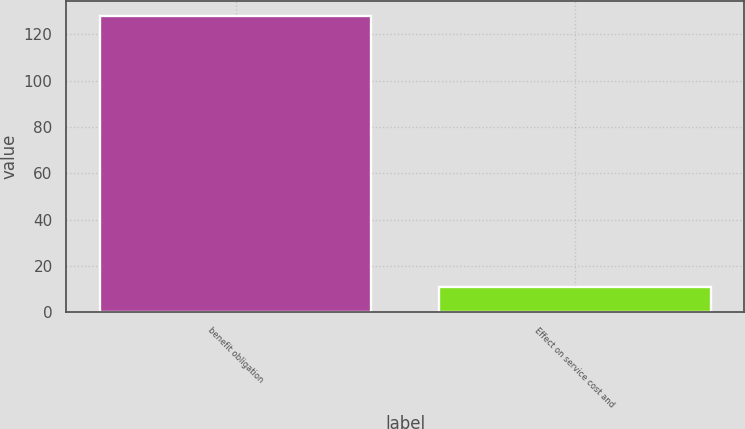<chart> <loc_0><loc_0><loc_500><loc_500><bar_chart><fcel>benefit obligation<fcel>Effect on service cost and<nl><fcel>128<fcel>11<nl></chart> 